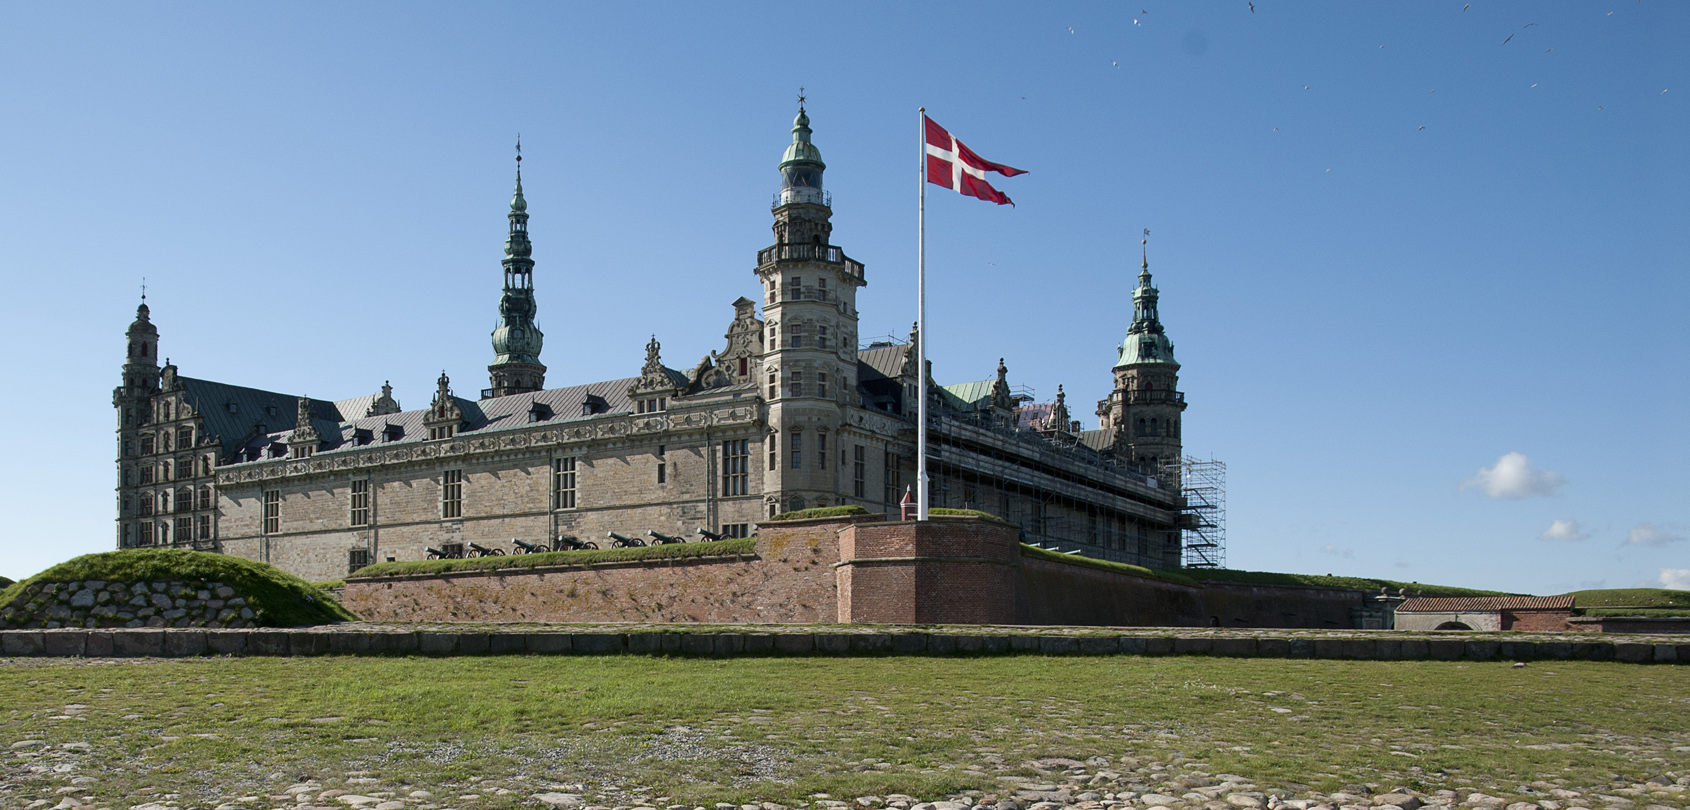If I were a bird soaring above this castle, what interesting details might catch my eye? As a bird flying high above Kronborg Castle, your sharp eyes would catch the intricate details of the castle’s architecture, including the ornate spires and battlements. You would observe the symmetry of the castle’s layout, surrounded by its protective moat with crystal-clear water reflecting the sky. The contrast of the green-roofed towers against the brown bricks would be striking from above. You might also notice the meticulous restoration work happening, with scaffolding meticulously placed around certain sections. The vast grassy plains, winding pathways, and the rhythmic fluttering of the Danish flag against the wind would create a picturesque sight from your vantage point. 